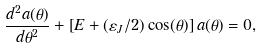<formula> <loc_0><loc_0><loc_500><loc_500>\frac { d ^ { 2 } a ( \theta ) } { d \theta ^ { 2 } } + \left [ E + ( \varepsilon _ { J } / 2 ) \cos ( \theta ) \right ] a ( \theta ) = 0 ,</formula> 